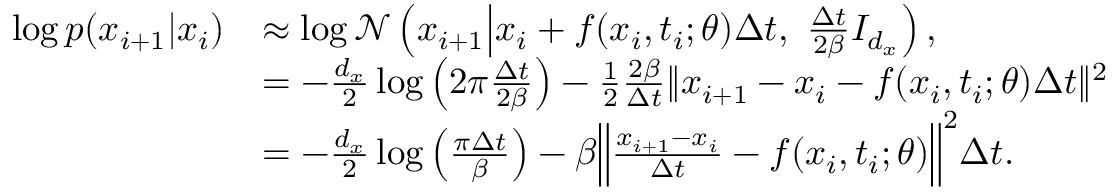<formula> <loc_0><loc_0><loc_500><loc_500>\begin{array} { r l } { \log p ( x _ { i + 1 } | x _ { i } ) } & { \approx \log \mathcal { N } \left ( x _ { i + 1 } | d l e | x _ { i } + f ( x _ { i } , t _ { i } ; \theta ) \Delta t , \ \frac { \Delta t } { 2 \beta } I _ { d _ { x } } \right ) , } \\ & { = - \frac { d _ { x } } { 2 } \log \left ( 2 \pi \frac { \Delta t } { 2 \beta } \right ) - \frac { 1 } { 2 } \frac { 2 \beta } { \Delta t } \| x _ { i + 1 } - x _ { i } - f ( x _ { i } , t _ { i } ; \theta ) \Delta t \| ^ { 2 } } \\ & { = - \frac { d _ { x } } { 2 } \log \left ( \frac { \pi \Delta t } { \beta } \right ) - \beta \left \| \frac { x _ { i + 1 } - x _ { i } } { \Delta t } - f ( x _ { i } , t _ { i } ; \theta ) \right \| ^ { 2 } \Delta t . } \end{array}</formula> 